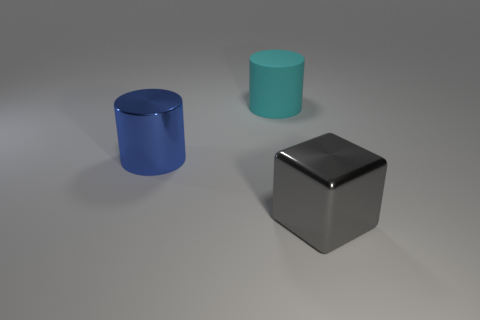Subtract all blue cylinders. How many cylinders are left? 1 Subtract all cylinders. How many objects are left? 1 Add 2 big metal cubes. How many objects exist? 5 Subtract 1 cubes. How many cubes are left? 0 Add 2 big cyan rubber objects. How many big cyan rubber objects are left? 3 Add 3 tiny blue matte blocks. How many tiny blue matte blocks exist? 3 Subtract 0 brown blocks. How many objects are left? 3 Subtract all yellow cylinders. Subtract all brown cubes. How many cylinders are left? 2 Subtract all cyan blocks. Subtract all blue shiny things. How many objects are left? 2 